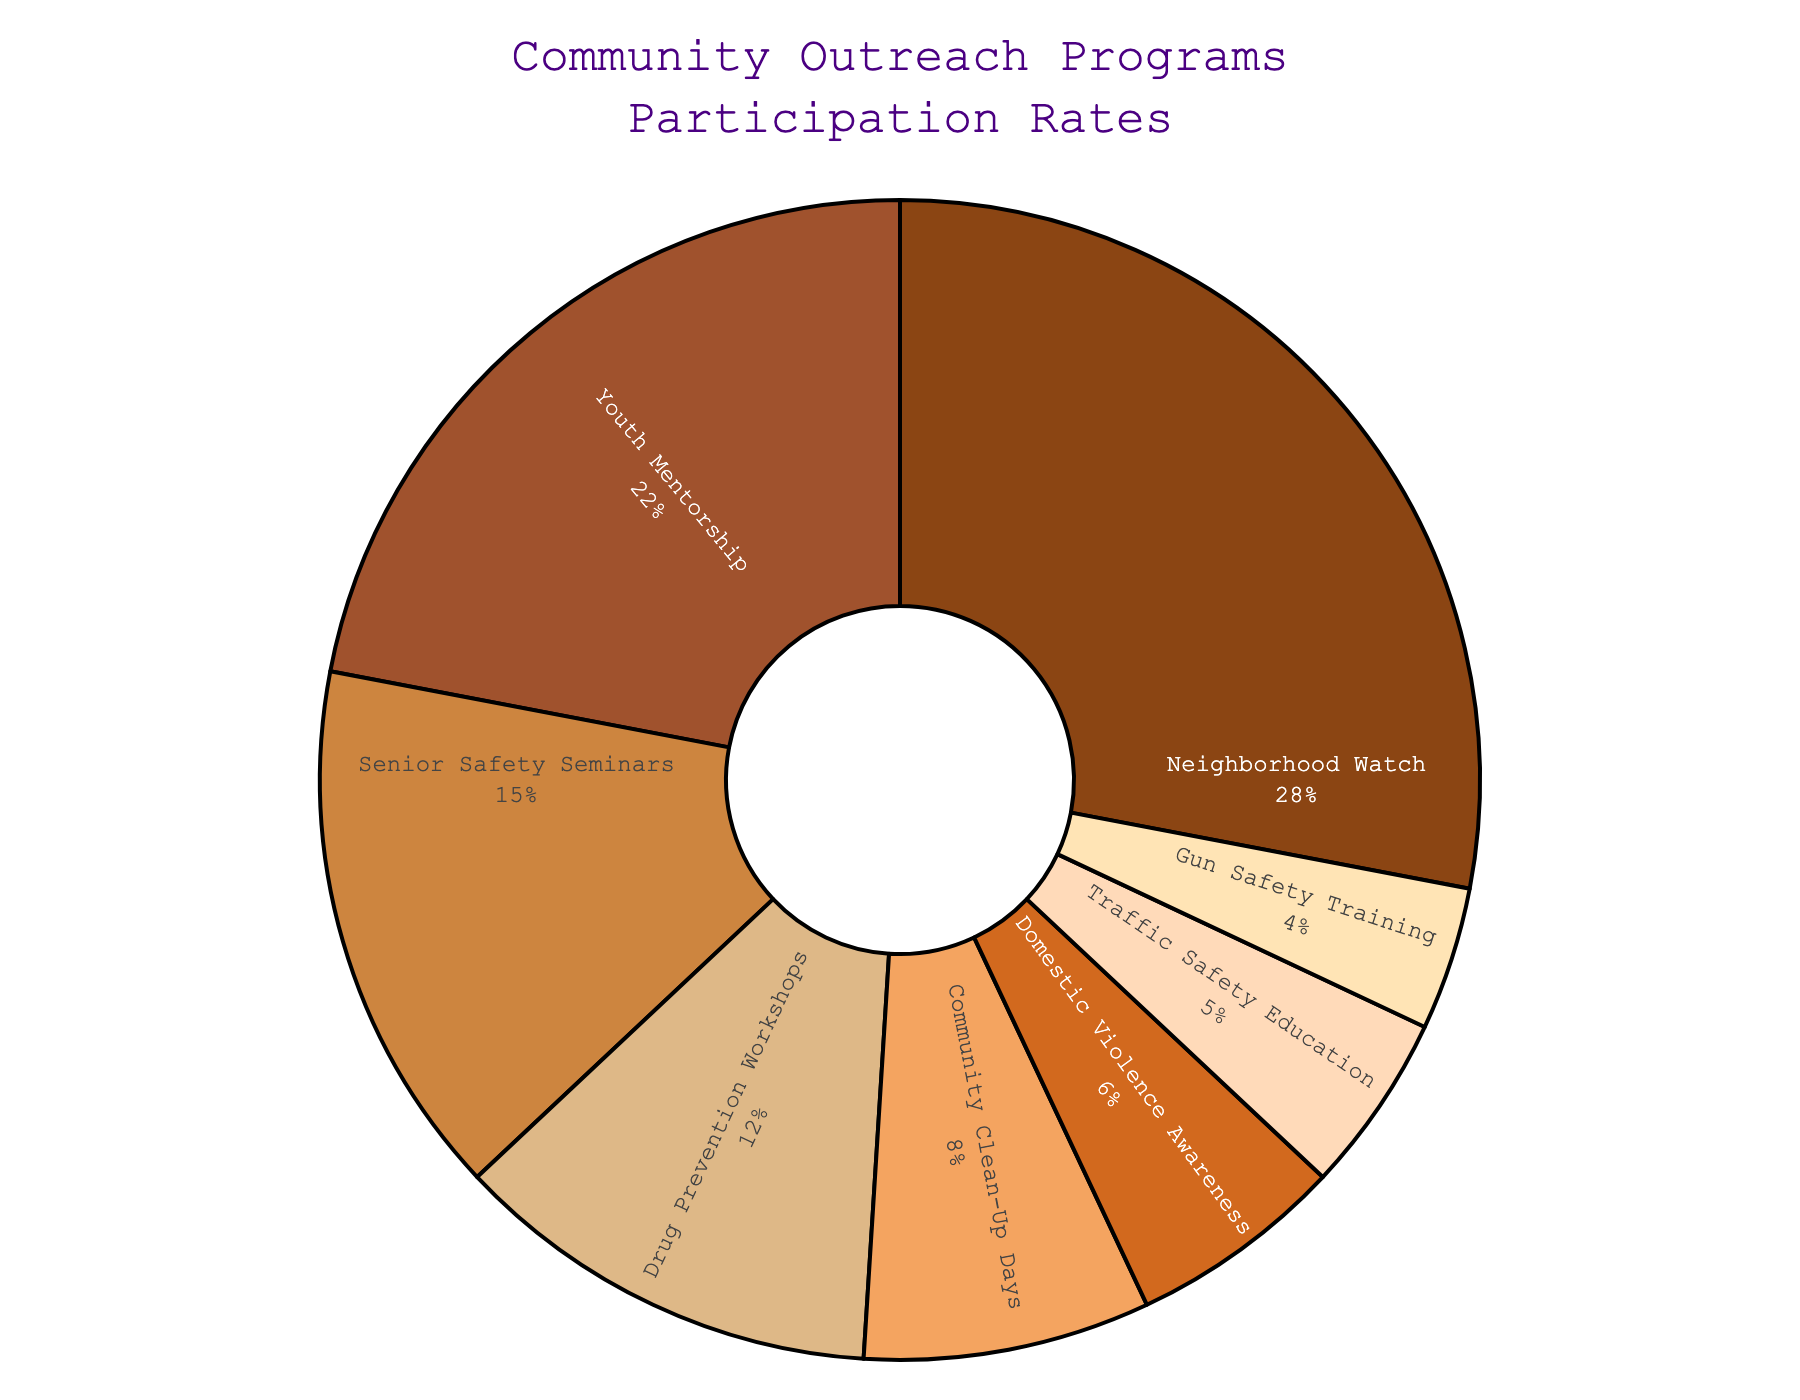What is the program with the highest participation rate? The pie chart shows Neighborhood Watch has the largest segment.
Answer: Neighborhood Watch How much higher is the participation rate of Youth Mentorship compared to Gun Safety Training? Youth Mentorship has a 22% rate, and Gun Safety Training has a 4% rate. The difference is 22% - 4% = 18%.
Answer: 18% Which three programs have the lowest participation rates? The smallest segments in the pie chart are Gun Safety Training (4%), Traffic Safety Education (5%), and Domestic Violence Awareness (6%).
Answer: Gun Safety Training, Traffic Safety Education, Domestic Violence Awareness What's the total participation rate for Senior Safety Seminars and Drug Prevention Workshops combined? Senior Safety Seminars have a 15% rate and Drug Prevention Workshops have a 12% rate. The sum is 15% + 12% = 27%.
Answer: 27% What percentage of the participation is for programs related to safety (Senior Safety Seminars, Traffic Safety Education, Gun Safety Training)? Adding their rates: Senior Safety Seminars (15%), Traffic Safety Education (5%), and Gun Safety Training (4%) gives 15% + 5% + 4% = 24%.
Answer: 24% Between Community Clean-Up Days and Domestic Violence Awareness, which has a higher participation rate? Community Clean-Up Days has an 8% rate, while Domestic Violence Awareness has 6%.
Answer: Community Clean-Up Days What is the sum of the participation rates for Neighborhood Watch, Youth Mentorship, and Domestic Violence Awareness? Neighborhood Watch (28%), Youth Mentorship (22%), and Domestic Violence Awareness (6%). The sum is 28% + 22% + 6% = 56%.
Answer: 56% Which program has a participation rate that is more than 3 times the rate of Gun Safety Training? Youth Mentorship has a 22% rate, which is more than 3 times the 4% rate of Gun Safety Training (4% * 3 = 12%, and 22% > 12%).
Answer: Youth Mentorship Which color in the pie chart represents Traffic Safety Education? From the chart, Traffic Safety Education is represented by the green-ish segment.
Answer: green-ish 